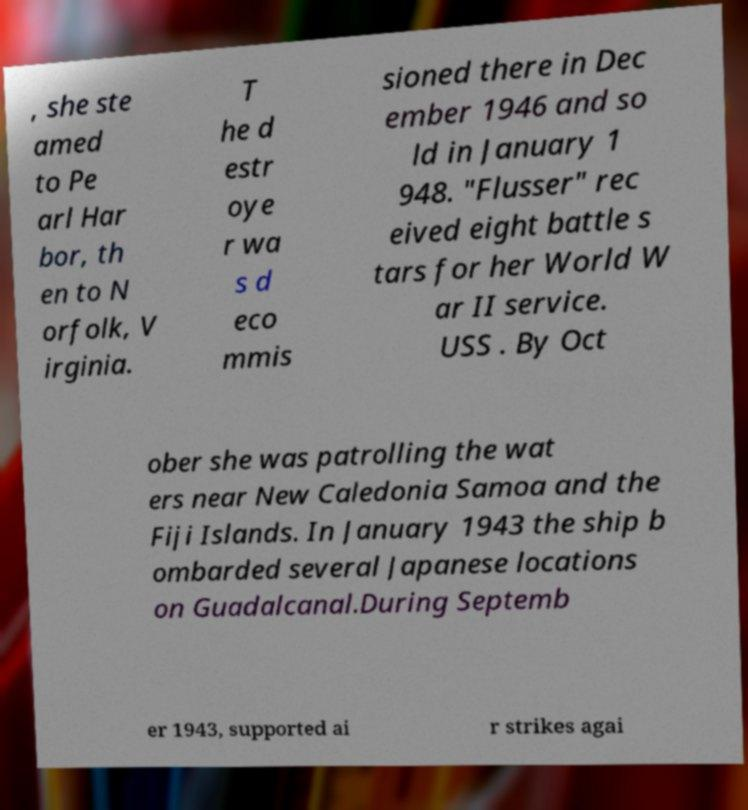There's text embedded in this image that I need extracted. Can you transcribe it verbatim? , she ste amed to Pe arl Har bor, th en to N orfolk, V irginia. T he d estr oye r wa s d eco mmis sioned there in Dec ember 1946 and so ld in January 1 948. "Flusser" rec eived eight battle s tars for her World W ar II service. USS . By Oct ober she was patrolling the wat ers near New Caledonia Samoa and the Fiji Islands. In January 1943 the ship b ombarded several Japanese locations on Guadalcanal.During Septemb er 1943, supported ai r strikes agai 